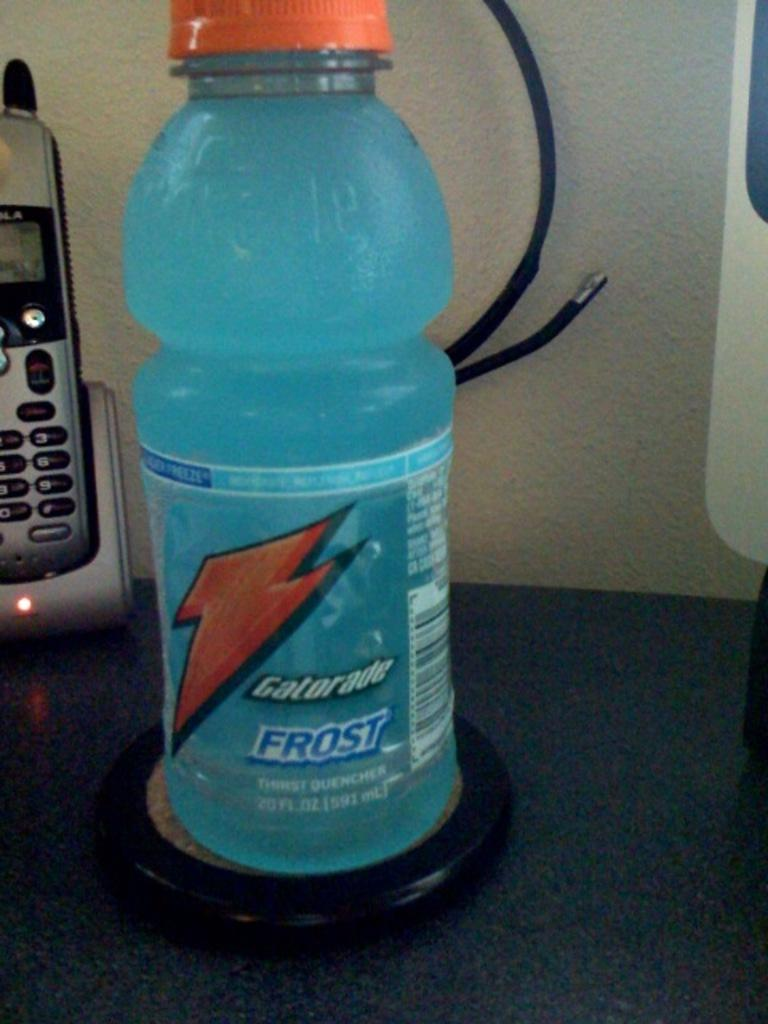<image>
Write a terse but informative summary of the picture. the blue Gatorade bottle sits on the table 